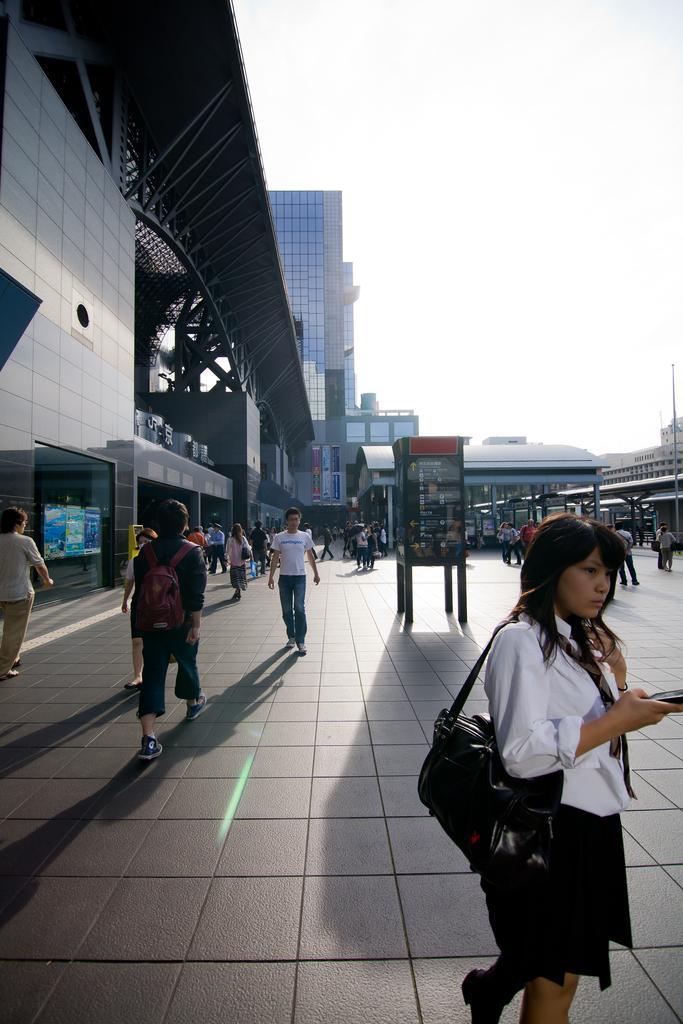In one or two sentences, can you explain what this image depicts? In this image there are so many people walking on the road, also there is a booth in the middle and some buildings around. 